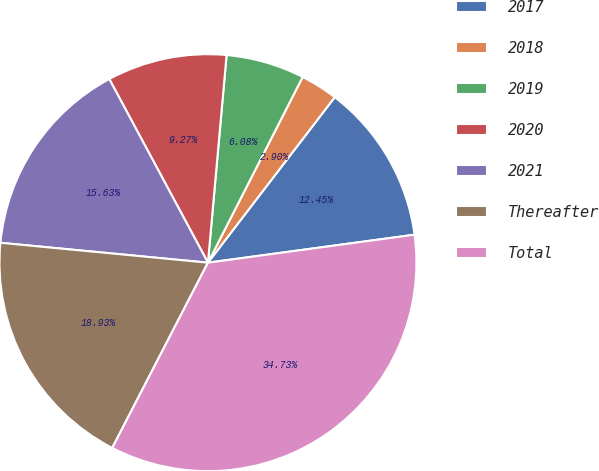Convert chart. <chart><loc_0><loc_0><loc_500><loc_500><pie_chart><fcel>2017<fcel>2018<fcel>2019<fcel>2020<fcel>2021<fcel>Thereafter<fcel>Total<nl><fcel>12.45%<fcel>2.9%<fcel>6.08%<fcel>9.27%<fcel>15.63%<fcel>18.93%<fcel>34.73%<nl></chart> 